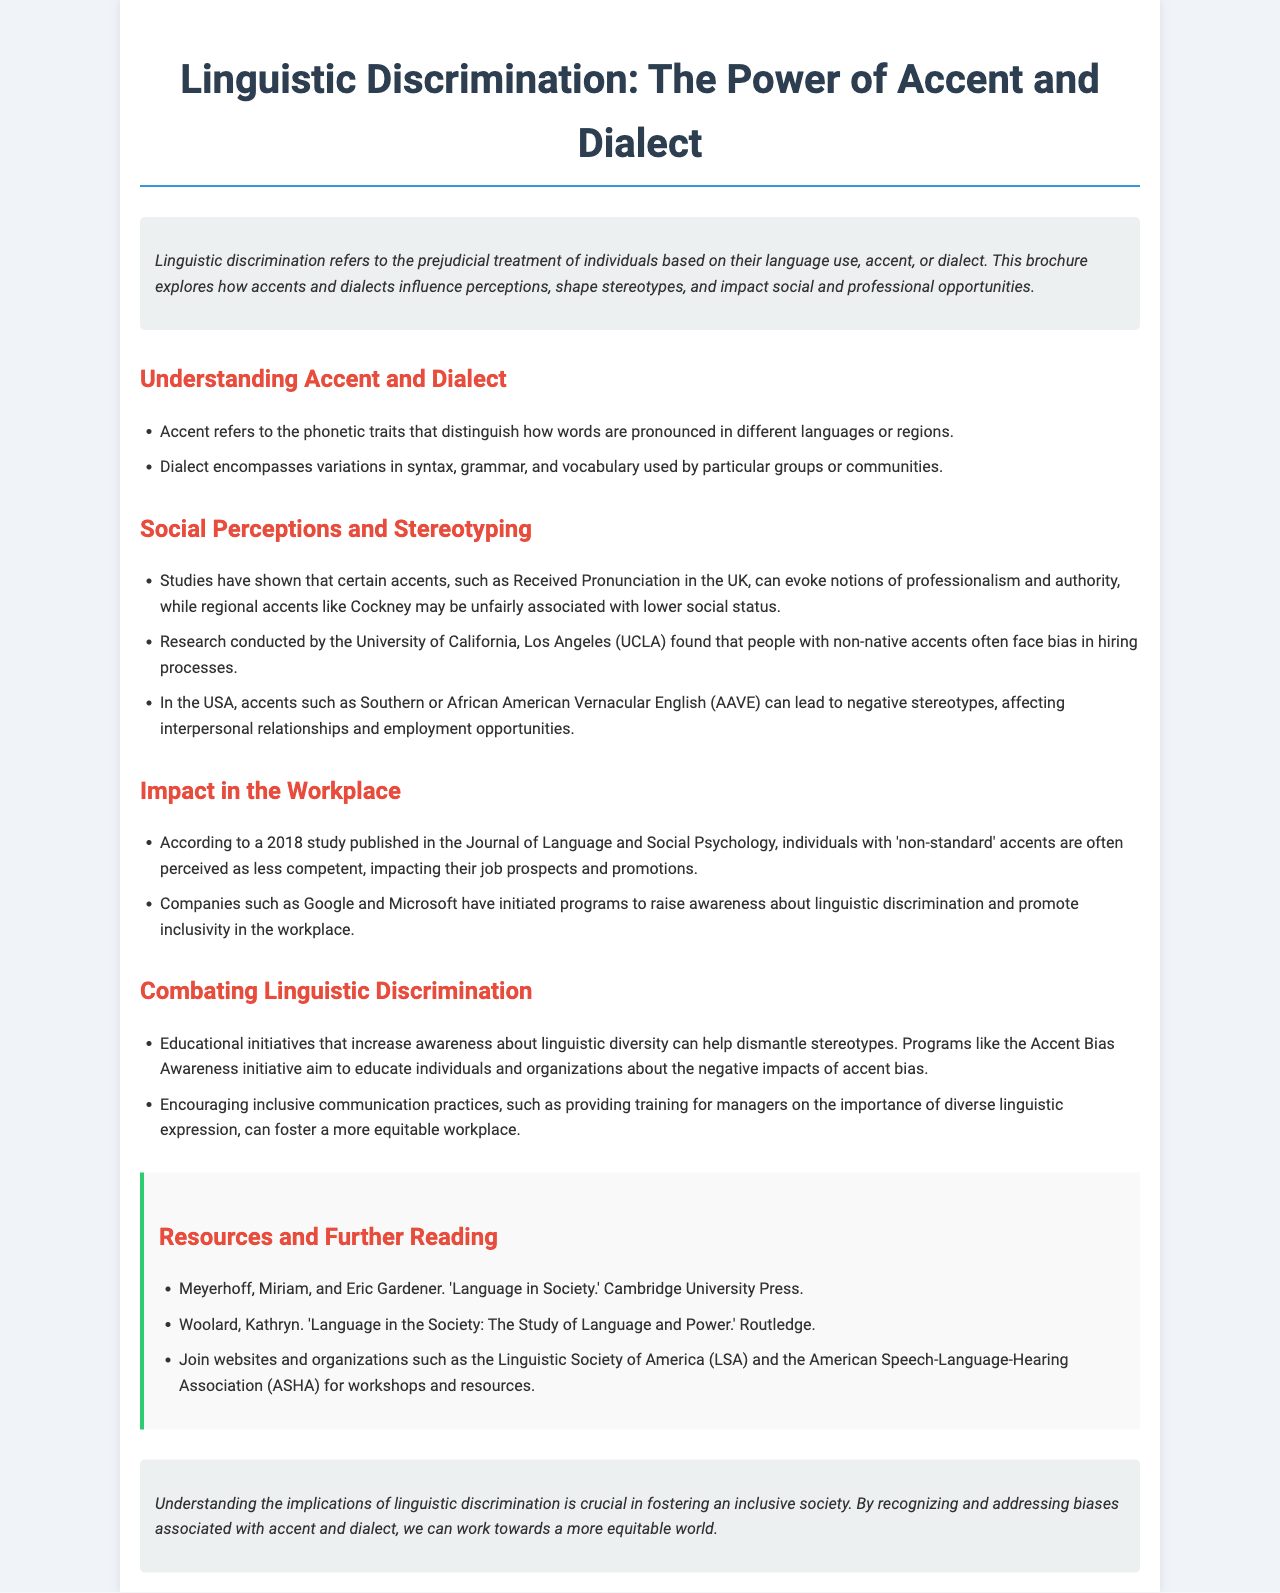what is the main topic of the brochure? The brochure explores the concept of how accents and dialects influence perceptions and stereotypes.
Answer: Linguistic discrimination what can accent refer to? Accent pertains to specific phonetic traits in language pronunciation that vary by region.
Answer: Phonetic traits what was found by research conducted by UCLA? The research indicates that individuals with non-native accents face bias in hiring processes.
Answer: Bias in hiring which study discussed the perception of 'non-standard' accents? A 2018 study published in the Journal of Language and Social Psychology addresses this perception.
Answer: Journal of Language and Social Psychology what initiative aims to increase awareness about linguistic diversity? The Accent Bias Awareness initiative is aimed at education on this topic.
Answer: Accent Bias Awareness name a company that has programs addressing linguistic discrimination. Google has initiated programs for this purpose.
Answer: Google how does the brochure define dialect? Dialect encompasses variations in syntax, grammar, and vocabulary among specific groups.
Answer: Variations in syntax, grammar, and vocabulary what type of communication practices does the brochure encourage? The brochure encourages inclusive communication practices such as training for managers.
Answer: Inclusive communication practices what is the publication year of the study mentioned under the workplace impact section? The mentioned study was published in 2018.
Answer: 2018 